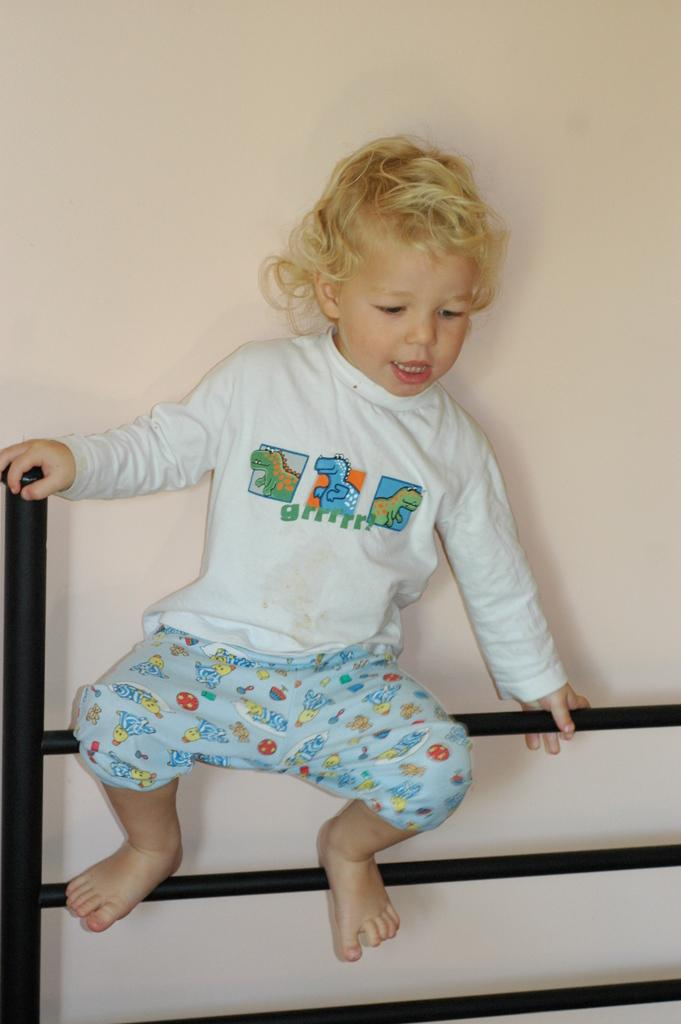Who is the main subject in the image? There is a boy in the image. What is the boy doing in the image? The boy is sitting on a metal rod. What can be seen in the background of the image? There is a wall in the background of the image. What type of mass is the boy attending in the image? There is no indication of a mass or any gathering in the image; it simply shows a boy sitting on a metal rod with a wall in the background. 